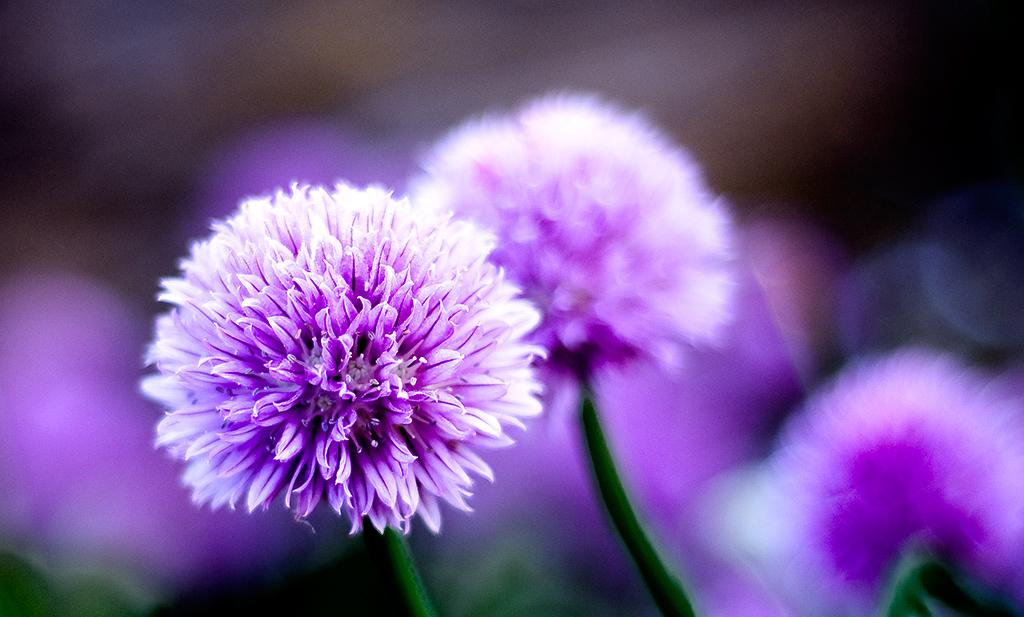What type of living organisms can be seen in the image? There are flowers in the image. Can you describe the background of the image? The background of the image is blurred. How many chairs are visible in the image? There are no chairs present in the image. Are there any cats interacting with the flowers in the image? There are no cats present in the image. 